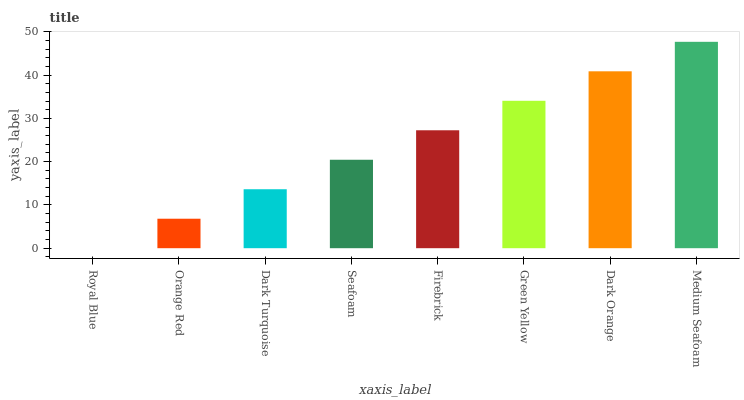Is Royal Blue the minimum?
Answer yes or no. Yes. Is Medium Seafoam the maximum?
Answer yes or no. Yes. Is Orange Red the minimum?
Answer yes or no. No. Is Orange Red the maximum?
Answer yes or no. No. Is Orange Red greater than Royal Blue?
Answer yes or no. Yes. Is Royal Blue less than Orange Red?
Answer yes or no. Yes. Is Royal Blue greater than Orange Red?
Answer yes or no. No. Is Orange Red less than Royal Blue?
Answer yes or no. No. Is Firebrick the high median?
Answer yes or no. Yes. Is Seafoam the low median?
Answer yes or no. Yes. Is Orange Red the high median?
Answer yes or no. No. Is Orange Red the low median?
Answer yes or no. No. 